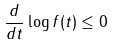Convert formula to latex. <formula><loc_0><loc_0><loc_500><loc_500>\frac { d } { d t } \log f ( t ) \leq 0</formula> 